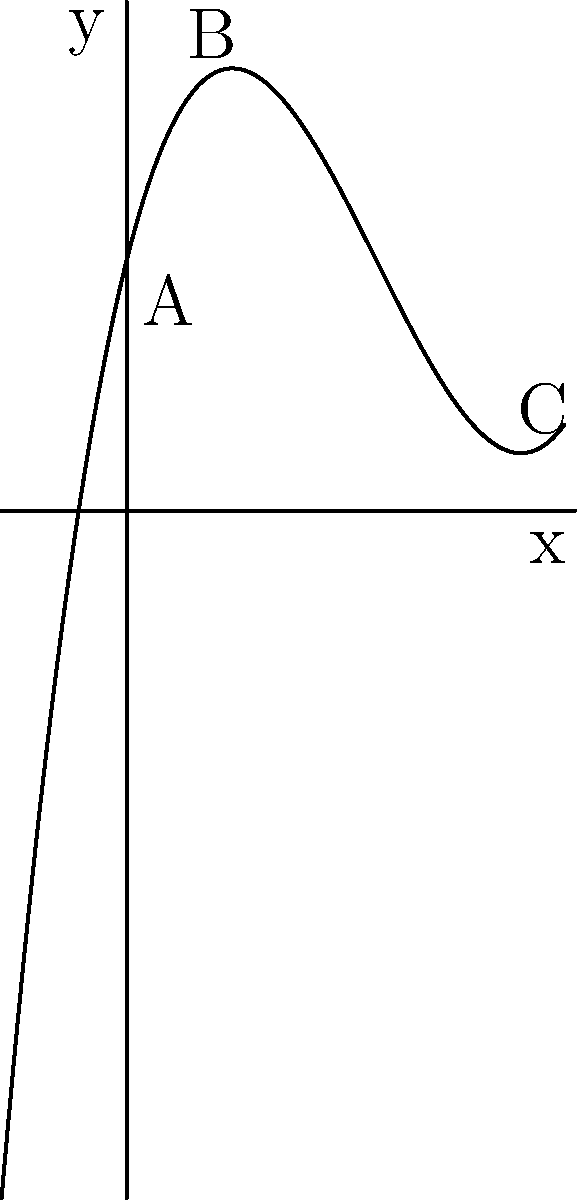In a new sci-fi film, you're working with the makeup artist to design a unique alien character. The thickness of the prosthetic makeup across the character's face is represented by the polynomial function $f(x) = 0.5x^3 - 3x^2 + 4x + 2$, where $x$ represents the horizontal position on the face (in cm) and $f(x)$ represents the thickness of the makeup (in mm). At which point on the face does the makeup reach its minimum thickness? To find the minimum thickness of the makeup, we need to follow these steps:

1) The minimum point of a polynomial function occurs where its first derivative equals zero and its second derivative is positive.

2) First, let's find the derivative of $f(x)$:
   $f'(x) = 1.5x^2 - 6x + 4$

3) Set $f'(x) = 0$ and solve for x:
   $1.5x^2 - 6x + 4 = 0$
   This is a quadratic equation. We can solve it using the quadratic formula:
   $x = \frac{-b \pm \sqrt{b^2 - 4ac}}{2a}$

4) Here, $a = 1.5$, $b = -6$, and $c = 4$
   $x = \frac{6 \pm \sqrt{36 - 24}}{3} = \frac{6 \pm \sqrt{12}}{3} = \frac{6 \pm 2\sqrt{3}}{3}$

5) This gives us two critical points:
   $x_1 = \frac{6 + 2\sqrt{3}}{3} \approx 2.15$ and $x_2 = \frac{6 - 2\sqrt{3}}{3} \approx 0.85$

6) To determine which one is the minimum, we need to check the second derivative:
   $f''(x) = 3x - 6$

7) At $x_2 \approx 0.85$:
   $f''(0.85) \approx 3(0.85) - 6 = -3.45 < 0$

8) At $x_1 \approx 2.15$:
   $f''(2.15) \approx 3(2.15) - 6 = 0.45 > 0$

Therefore, the minimum point occurs at $x_1 \approx 2.15$ cm from the left side of the face.
Answer: 2.15 cm from the left side of the face 